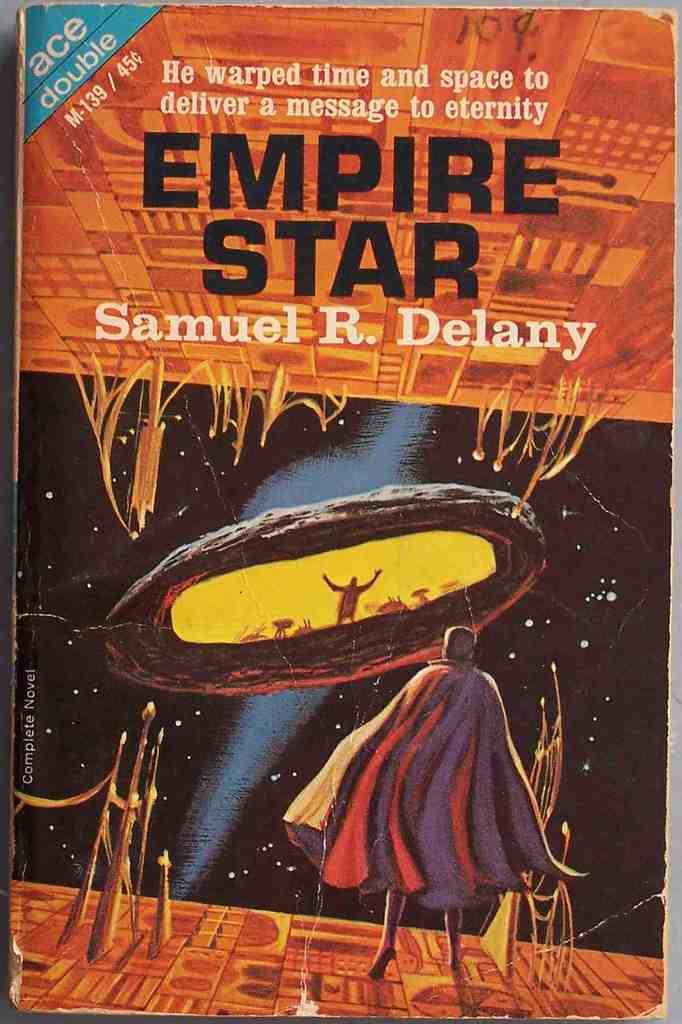Who is the author of this book?
Provide a succinct answer. Samuel r. delany. 